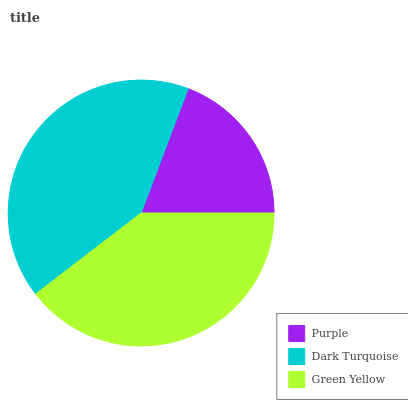Is Purple the minimum?
Answer yes or no. Yes. Is Dark Turquoise the maximum?
Answer yes or no. Yes. Is Green Yellow the minimum?
Answer yes or no. No. Is Green Yellow the maximum?
Answer yes or no. No. Is Dark Turquoise greater than Green Yellow?
Answer yes or no. Yes. Is Green Yellow less than Dark Turquoise?
Answer yes or no. Yes. Is Green Yellow greater than Dark Turquoise?
Answer yes or no. No. Is Dark Turquoise less than Green Yellow?
Answer yes or no. No. Is Green Yellow the high median?
Answer yes or no. Yes. Is Green Yellow the low median?
Answer yes or no. Yes. Is Dark Turquoise the high median?
Answer yes or no. No. Is Dark Turquoise the low median?
Answer yes or no. No. 